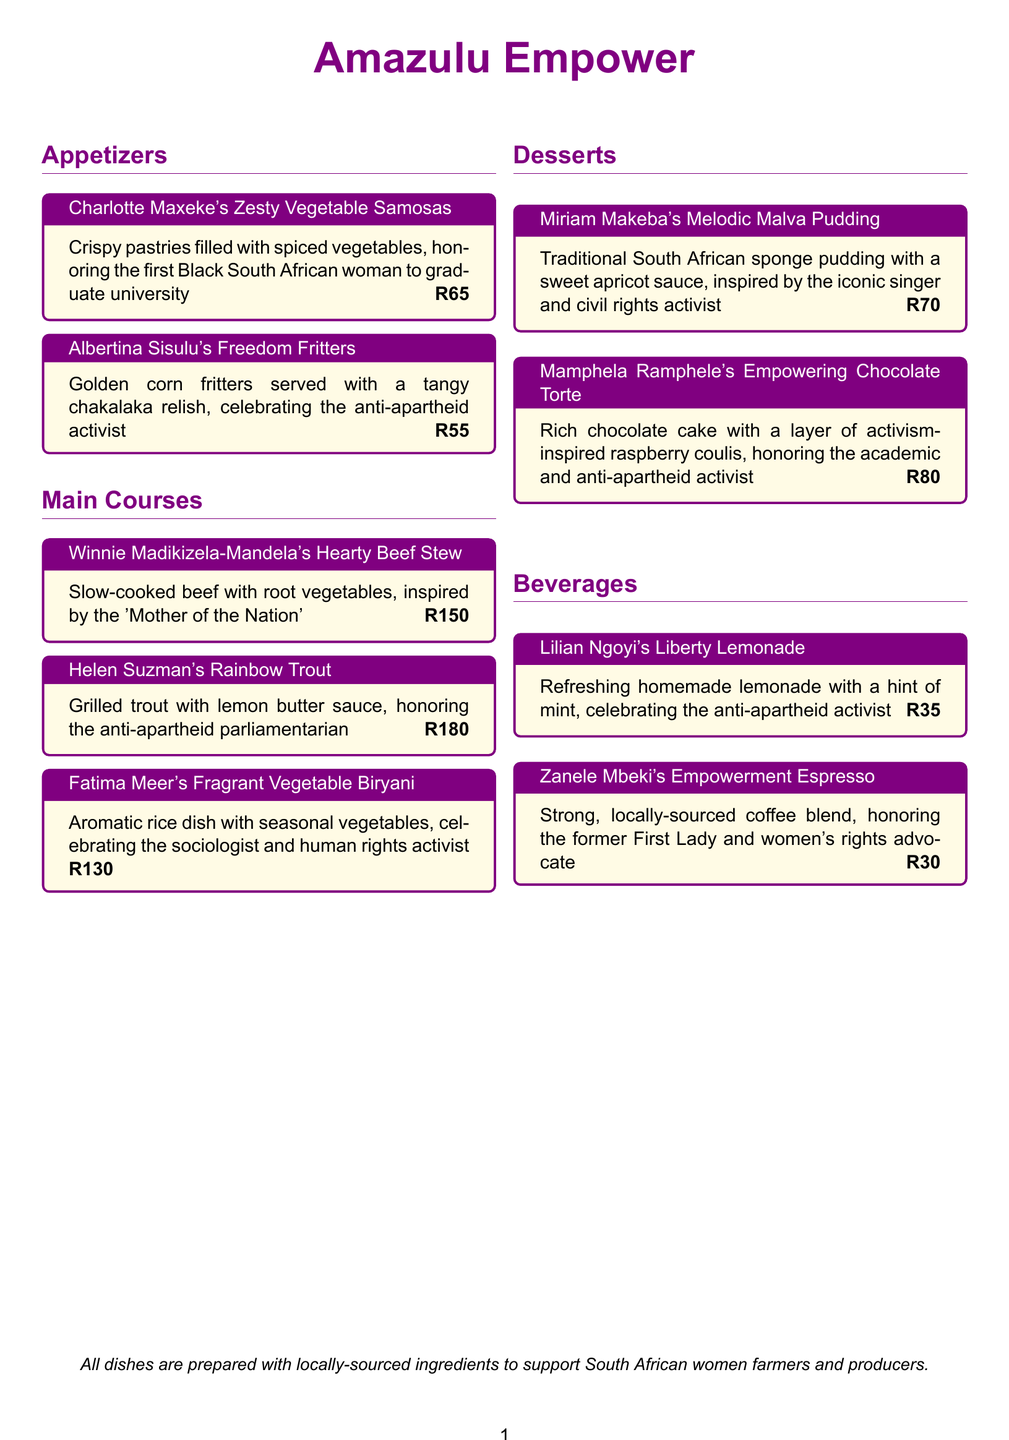What is the name of the appetizer dedicated to the first Black South African woman to graduate university? The appetizer is named "Charlotte Maxeke's Zesty Vegetable Samosas."
Answer: Charlotte Maxeke's Zesty Vegetable Samosas What is the price of Albertina Sisulu's Freedom Fritters? The document states that the price for this dish is R55.
Answer: R55 Which main course is inspired by the 'Mother of the Nation'? The main course is "Winnie Madikizela-Mandela's Hearty Beef Stew."
Answer: Winnie Madikizela-Mandela's Hearty Beef Stew How many desserts are featured on the menu? The menu lists two desserts: Malva Pudding and Chocolate Torte.
Answer: 2 What type of beverage is dedicated to the former First Lady and women's rights advocate? The beverage is "Zanele Mbeki's Empowerment Espresso."
Answer: Zanele Mbeki's Empowerment Espresso Which dish celebrates the sociologist and human rights activist? The dish is "Fatima Meer's Fragrant Vegetable Biryani."
Answer: Fatima Meer's Fragrant Vegetable Biryani What is the color of the section titles in the menu? The section titles are in empowerPurple color.
Answer: empowerPurple What is the primary theme of the restaurant menu? The theme of the menu is empowerment, focusing on influential South African women activists.
Answer: Empowerment What unique feature do all dishes on the menu share? All dishes are prepared with locally-sourced ingredients.
Answer: Locally-sourced ingredients 